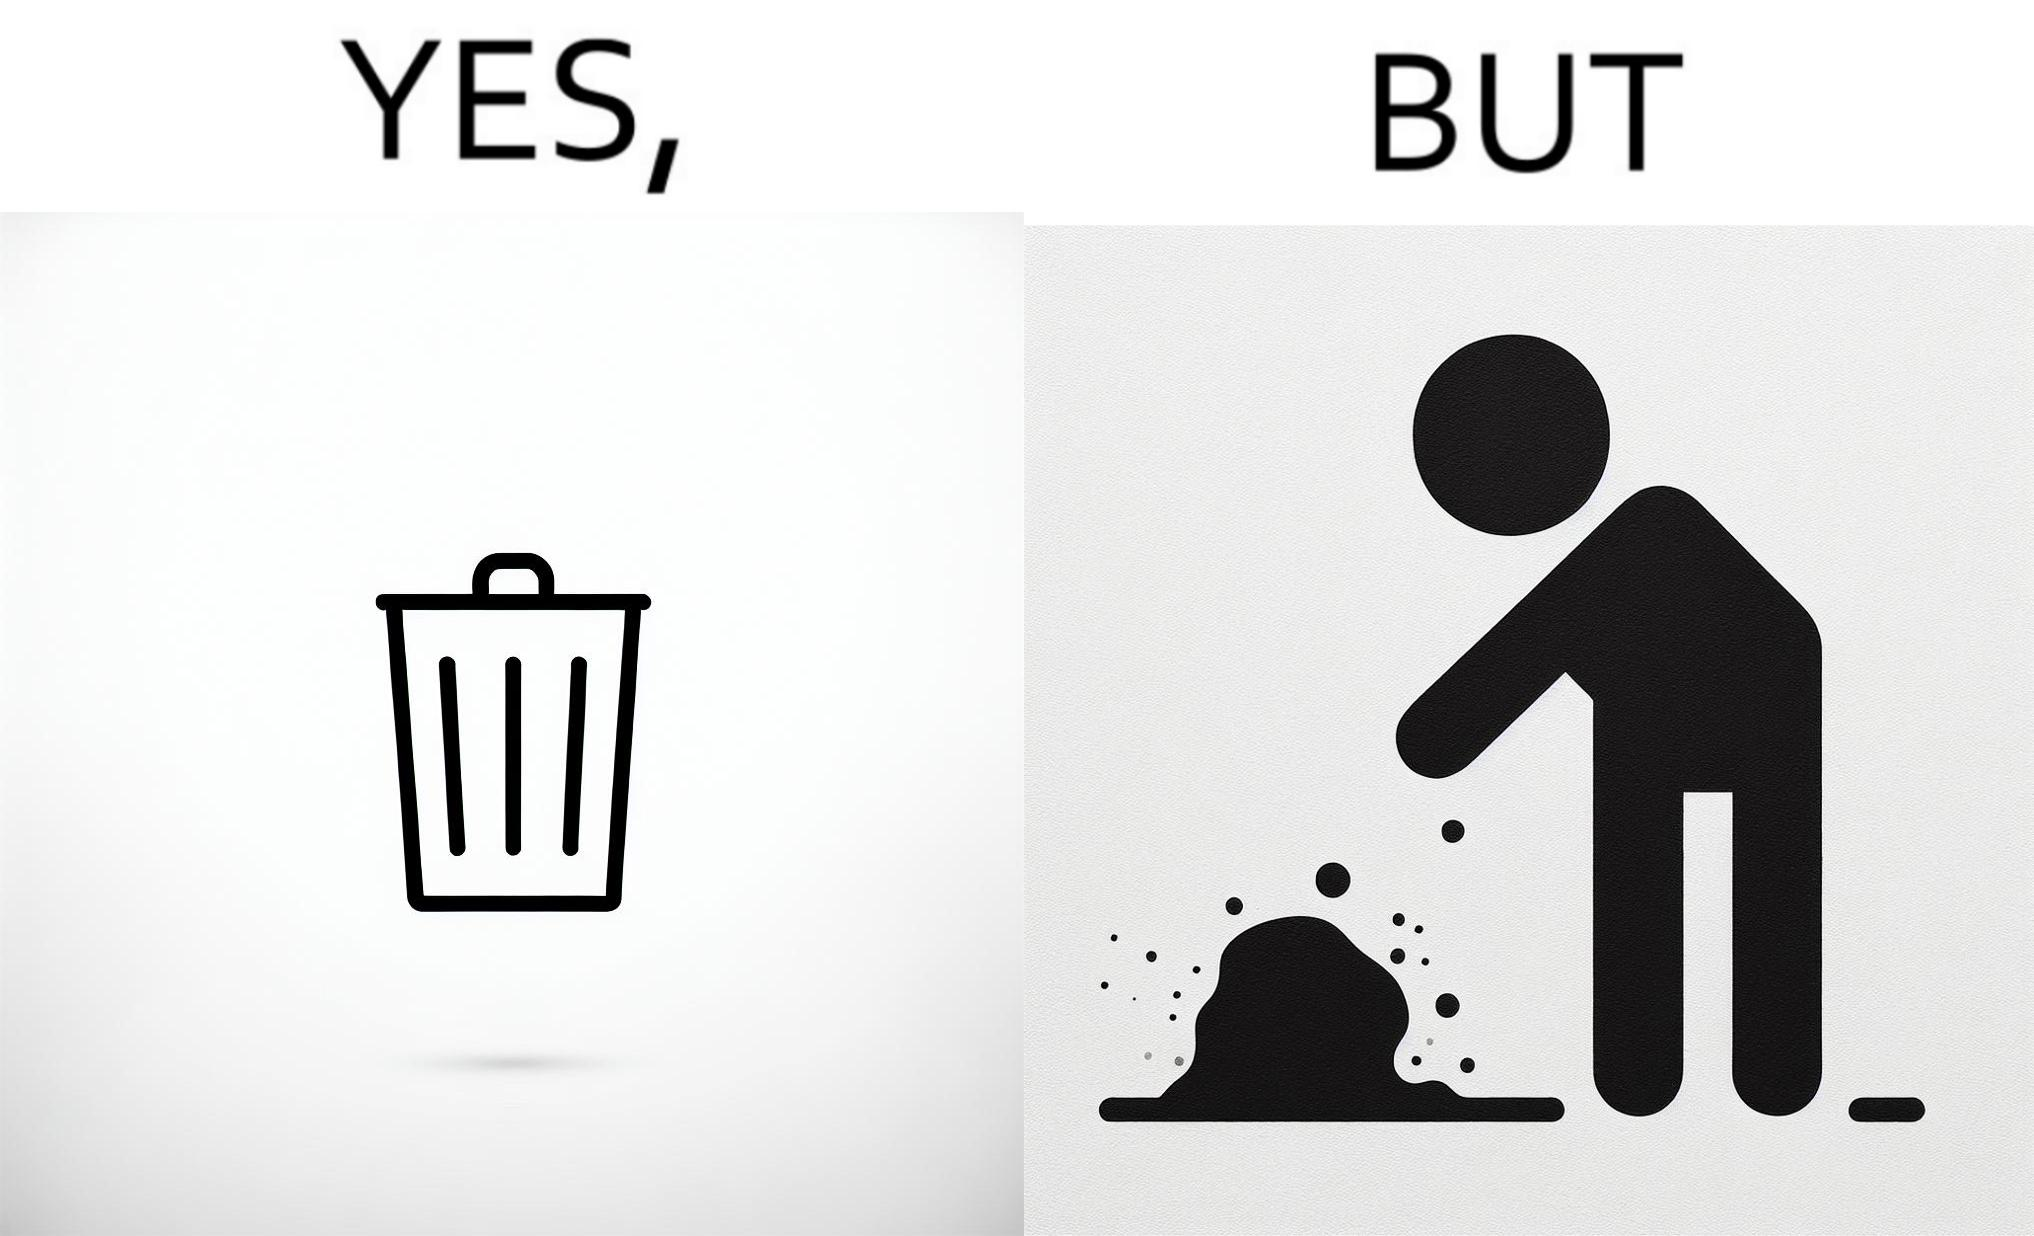Describe what you see in the left and right parts of this image. In the left part of the image: It is a garbage bin In the right part of the image: It is a human hand sticking chewing gum on public property 